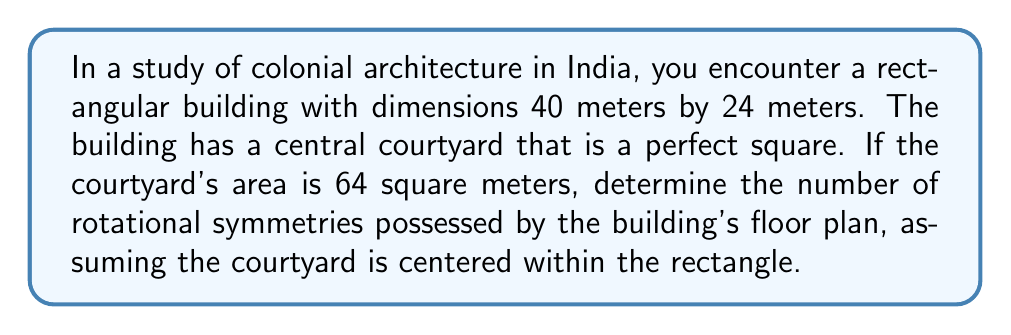Could you help me with this problem? Let's approach this step-by-step:

1) First, we need to understand the layout. We have a rectangle (the building) with a square (the courtyard) in the center.

2) The building dimensions are 40m x 24m.

3) The courtyard is a square with an area of 64 square meters.

4) To find the side length of the square courtyard:
   $$ A = s^2 $$
   $$ 64 = s^2 $$
   $$ s = \sqrt{64} = 8 \text{ meters} $$

5) Now, let's visualize the floor plan:

   [asy]
   size(200);
   pen thickpen = linewidth(0.7);
   draw((0,0)--(40,0)--(40,24)--(0,24)--cycle, thickpen);
   draw((16,8)--(24,8)--(24,16)--(16,16)--cycle, thickpen);
   label("40m", (20,-2));
   label("24m", (42,12), E);
   label("8m", (20,8), N);
   [/asy]

6) To determine rotational symmetry, we need to check how many times the shape can be rotated onto itself in a full 360° rotation.

7) In this case, the building has two-fold rotational symmetry (180° rotation):
   - 0° (original position)
   - 180° (upside down)

8) It does not have four-fold rotational symmetry (90° rotations) because the outer rectangle is not a square.

Therefore, the building's floor plan has 2 rotational symmetries.
Answer: 2 